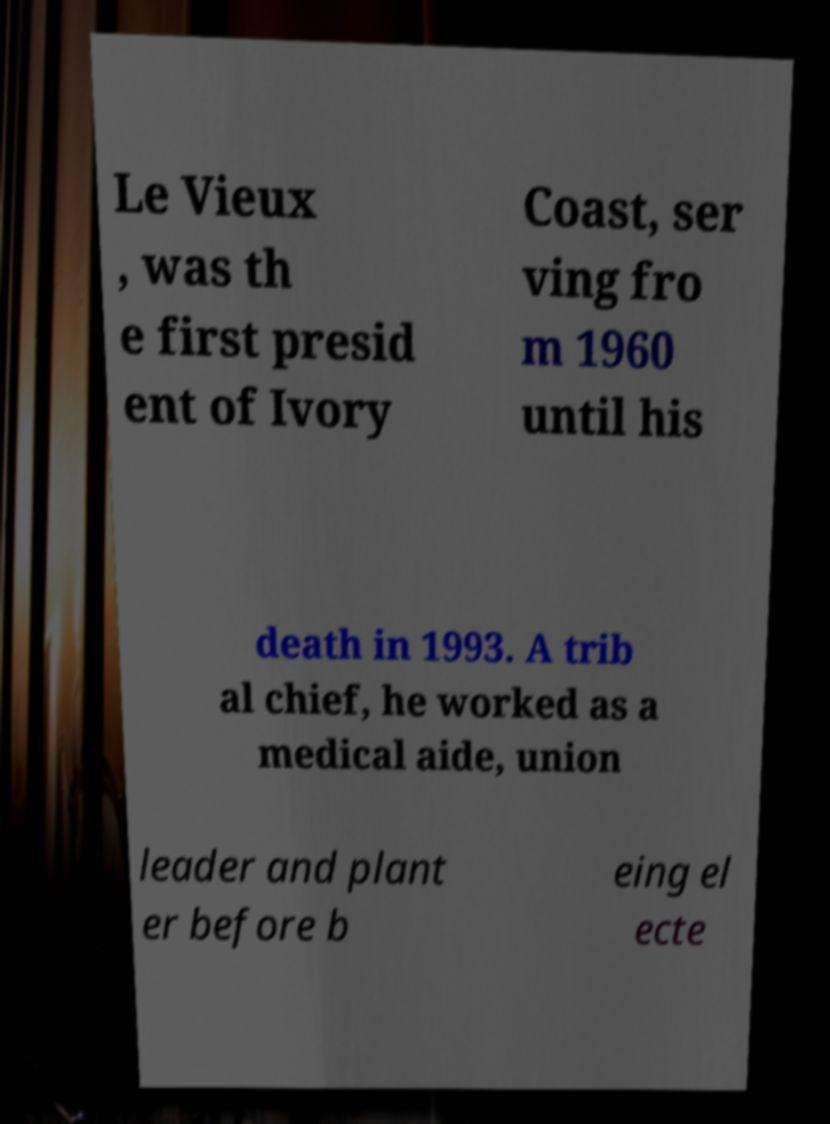Please read and relay the text visible in this image. What does it say? Le Vieux , was th e first presid ent of Ivory Coast, ser ving fro m 1960 until his death in 1993. A trib al chief, he worked as a medical aide, union leader and plant er before b eing el ecte 